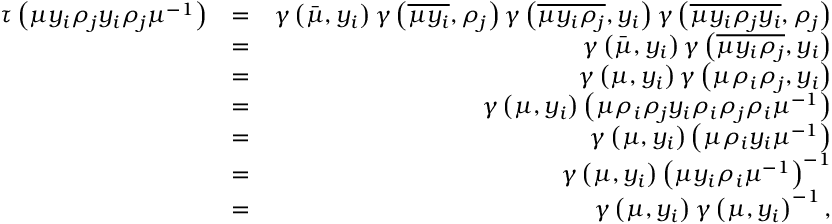<formula> <loc_0><loc_0><loc_500><loc_500>\begin{array} { r l r } { \tau \left ( \mu y _ { i } \rho _ { j } y _ { i } \rho _ { j } \mu ^ { - 1 } \right ) } & { = } & { \gamma \left ( \bar { \mu } , y _ { i } \right ) \gamma \left ( \overline { { \mu y _ { i } } } , \rho _ { j } \right ) \gamma \left ( \overline { { \mu y _ { i } \rho _ { j } } } , y _ { i } \right ) \gamma \left ( \overline { { \mu y _ { i } \rho _ { j } y _ { i } } } , \rho _ { j } \right ) } \\ & { = } & { \gamma \left ( \bar { \mu } , y _ { i } \right ) \gamma \left ( \overline { { \mu y _ { i } \rho _ { j } } } , y _ { i } \right ) } \\ & { = } & { \gamma \left ( \mu , y _ { i } \right ) \gamma \left ( \mu \rho _ { i } \rho _ { j } , y _ { i } \right ) } \\ & { = } & { \gamma \left ( \mu , y _ { i } \right ) \left ( \mu \rho _ { i } \rho _ { j } y _ { i } \rho _ { i } \rho _ { j } \rho _ { i } \mu ^ { - 1 } \right ) } \\ & { = } & { \gamma \left ( \mu , y _ { i } \right ) \left ( \mu \rho _ { i } y _ { i } \mu ^ { - 1 } \right ) } \\ & { = } & { \gamma \left ( \mu , y _ { i } \right ) \left ( \mu y _ { i } \rho _ { i } \mu ^ { - 1 } \right ) ^ { - 1 } } \\ & { = } & { \gamma \left ( \mu , y _ { i } \right ) \gamma \left ( \mu , y _ { i } \right ) ^ { - 1 } , } \end{array}</formula> 